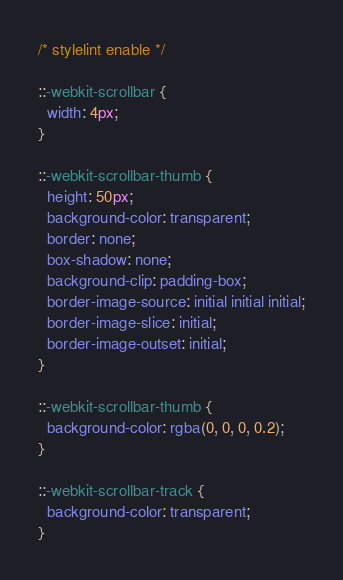<code> <loc_0><loc_0><loc_500><loc_500><_CSS_>/* stylelint enable */

::-webkit-scrollbar {
  width: 4px;
}

::-webkit-scrollbar-thumb {
  height: 50px;
  background-color: transparent;
  border: none;
  box-shadow: none;
  background-clip: padding-box;
  border-image-source: initial initial initial;
  border-image-slice: initial;
  border-image-outset: initial;
}

::-webkit-scrollbar-thumb {
  background-color: rgba(0, 0, 0, 0.2);
}

::-webkit-scrollbar-track {
  background-color: transparent;
}
</code> 